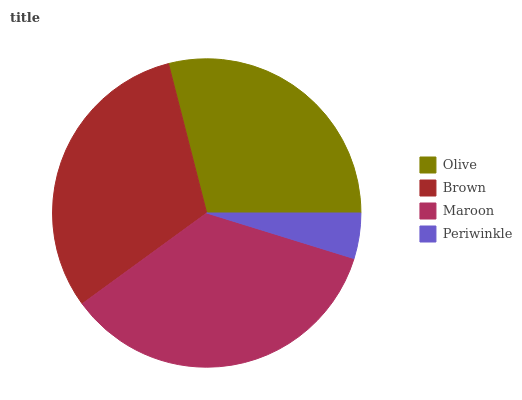Is Periwinkle the minimum?
Answer yes or no. Yes. Is Maroon the maximum?
Answer yes or no. Yes. Is Brown the minimum?
Answer yes or no. No. Is Brown the maximum?
Answer yes or no. No. Is Brown greater than Olive?
Answer yes or no. Yes. Is Olive less than Brown?
Answer yes or no. Yes. Is Olive greater than Brown?
Answer yes or no. No. Is Brown less than Olive?
Answer yes or no. No. Is Brown the high median?
Answer yes or no. Yes. Is Olive the low median?
Answer yes or no. Yes. Is Periwinkle the high median?
Answer yes or no. No. Is Brown the low median?
Answer yes or no. No. 